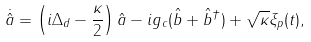Convert formula to latex. <formula><loc_0><loc_0><loc_500><loc_500>\dot { \hat { a } } = \left ( i \Delta _ { d } - \frac { \kappa } { 2 } \right ) \hat { a } - i g _ { c } ( \hat { b } + \hat { b } ^ { \dagger } ) + \sqrt { \kappa } \xi _ { p } ( t ) ,</formula> 